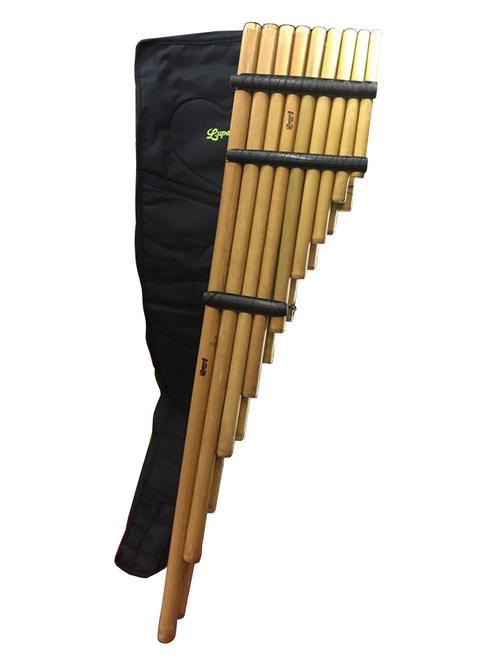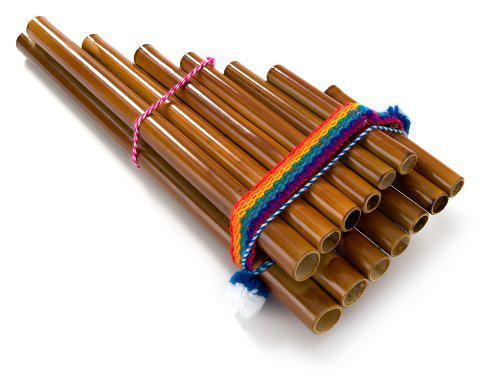The first image is the image on the left, the second image is the image on the right. Assess this claim about the two images: "A carrying bag sits under the instrument in the image on the left.". Correct or not? Answer yes or no. Yes. The first image is the image on the left, the second image is the image on the right. For the images displayed, is the sentence "The right image features an instrument with pom-pom balls on each side displayed vertically, with its wooden tube shapes arranged left-to-right from shortest to longest." factually correct? Answer yes or no. No. 